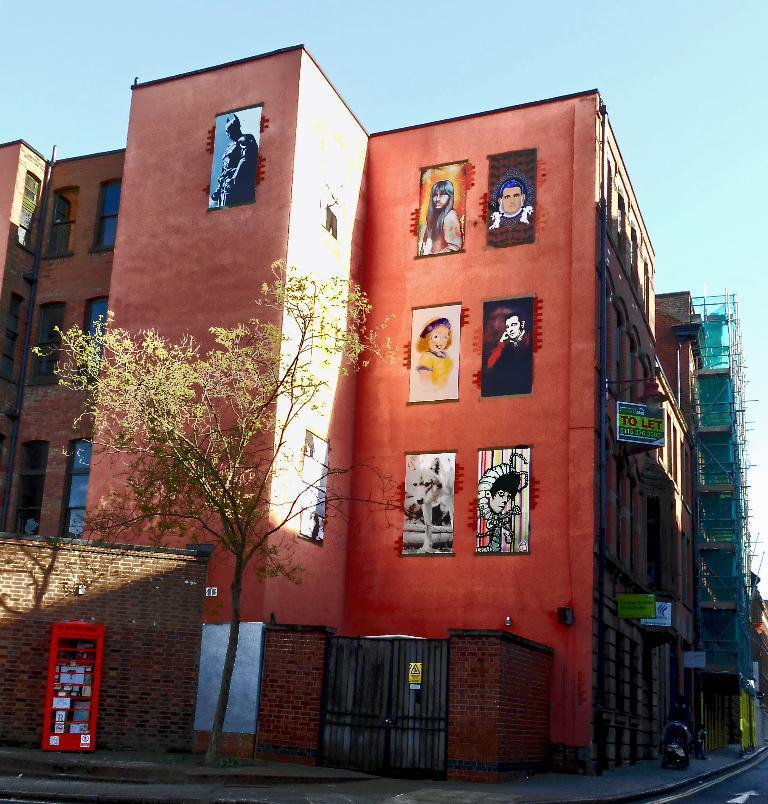Could you give a brief overview of what you see in this image? In this picture, we can see a few buildings, and among them we can a building with images, we can see posters with some text, house, gate, pole, tree, road a few people, and vehicle. 